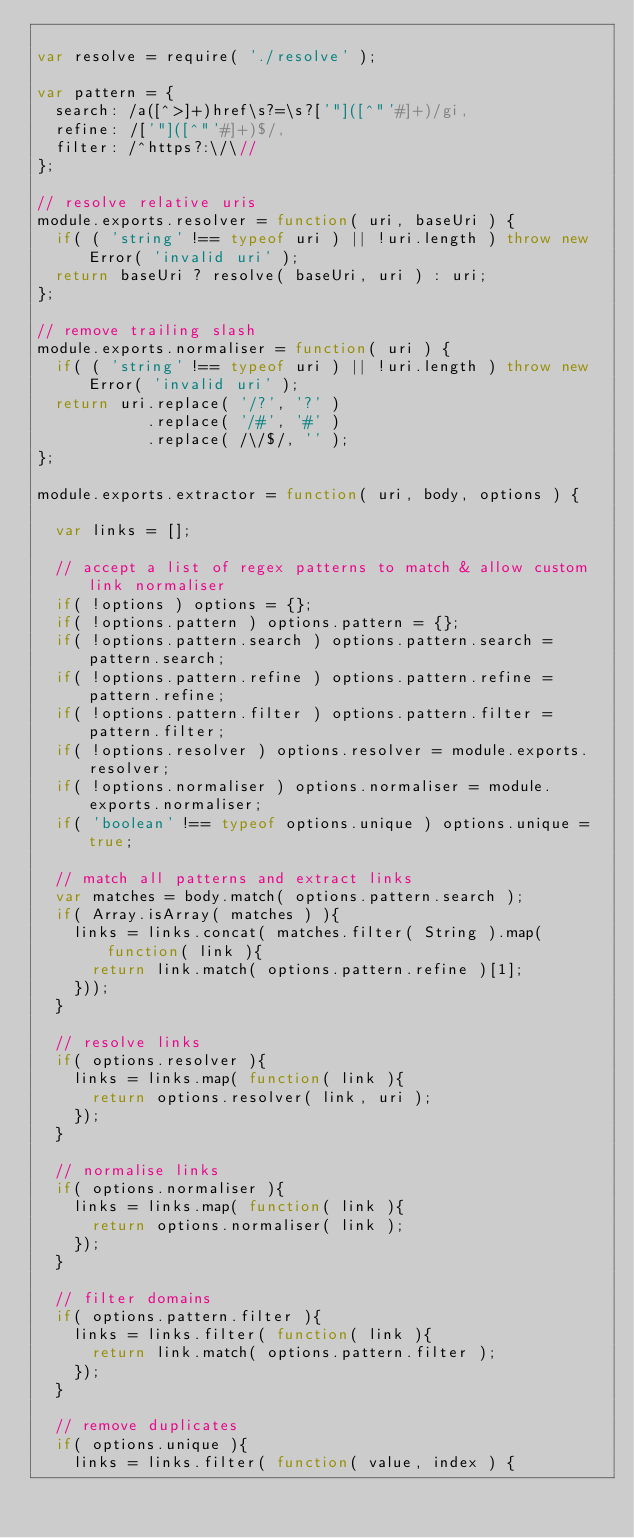<code> <loc_0><loc_0><loc_500><loc_500><_JavaScript_>
var resolve = require( './resolve' );

var pattern = {
  search: /a([^>]+)href\s?=\s?['"]([^"'#]+)/gi,
  refine: /['"]([^"'#]+)$/,
  filter: /^https?:\/\//
};

// resolve relative uris
module.exports.resolver = function( uri, baseUri ) {
  if( ( 'string' !== typeof uri ) || !uri.length ) throw new Error( 'invalid uri' );
  return baseUri ? resolve( baseUri, uri ) : uri;
};

// remove trailing slash
module.exports.normaliser = function( uri ) {
  if( ( 'string' !== typeof uri ) || !uri.length ) throw new Error( 'invalid uri' );
  return uri.replace( '/?', '?' )
            .replace( '/#', '#' )
            .replace( /\/$/, '' );
};

module.exports.extractor = function( uri, body, options ) {

  var links = [];

  // accept a list of regex patterns to match & allow custom link normaliser
  if( !options ) options = {};
  if( !options.pattern ) options.pattern = {};
  if( !options.pattern.search ) options.pattern.search = pattern.search;
  if( !options.pattern.refine ) options.pattern.refine = pattern.refine;
  if( !options.pattern.filter ) options.pattern.filter = pattern.filter;
  if( !options.resolver ) options.resolver = module.exports.resolver;
  if( !options.normaliser ) options.normaliser = module.exports.normaliser;
  if( 'boolean' !== typeof options.unique ) options.unique = true;

  // match all patterns and extract links
  var matches = body.match( options.pattern.search );
  if( Array.isArray( matches ) ){
    links = links.concat( matches.filter( String ).map( function( link ){
      return link.match( options.pattern.refine )[1];
    }));
  }

  // resolve links
  if( options.resolver ){
    links = links.map( function( link ){
      return options.resolver( link, uri );
    });
  }

  // normalise links
  if( options.normaliser ){
    links = links.map( function( link ){
      return options.normaliser( link );
    });
  }

  // filter domains
  if( options.pattern.filter ){
    links = links.filter( function( link ){
      return link.match( options.pattern.filter );
    });
  }

  // remove duplicates
  if( options.unique ){
    links = links.filter( function( value, index ) {</code> 